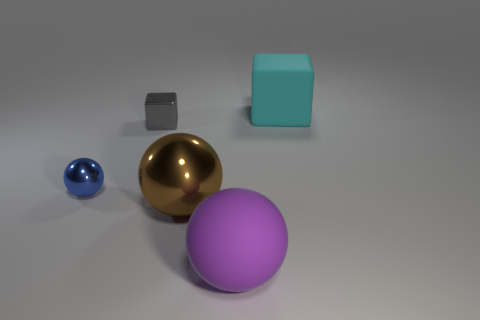Is there anything else that is the same size as the brown shiny sphere?
Provide a succinct answer. Yes. The tiny gray thing has what shape?
Your response must be concise. Cube. There is a large object behind the blue metal sphere; what is its material?
Your answer should be compact. Rubber. There is a matte object that is to the left of the big matte object to the right of the rubber object that is in front of the small blue metal ball; how big is it?
Your response must be concise. Large. Does the big object that is behind the small blue object have the same material as the brown object right of the blue metallic thing?
Your response must be concise. No. What number of other objects are there of the same color as the tiny sphere?
Ensure brevity in your answer.  0. How many objects are either big rubber objects in front of the cyan matte cube or things that are behind the small gray cube?
Keep it short and to the point. 2. How big is the thing to the right of the big ball in front of the brown object?
Keep it short and to the point. Large. How big is the rubber sphere?
Your response must be concise. Large. Does the big rubber object behind the small gray thing have the same color as the metal object in front of the small blue thing?
Provide a succinct answer. No. 